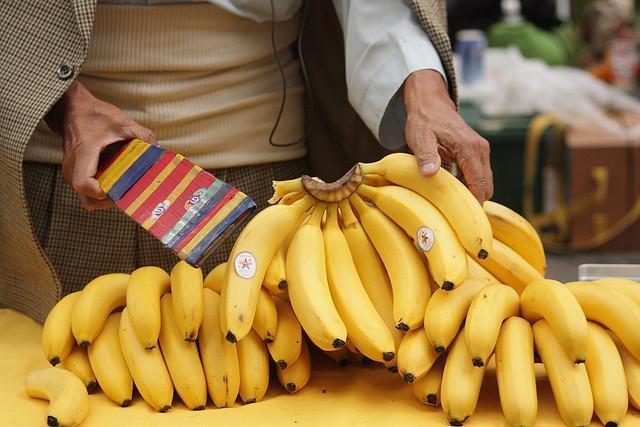How many stickers are shown on the fruit?
Give a very brief answer. 2. How many bananas are in the photo?
Give a very brief answer. 7. How many carrots are there?
Give a very brief answer. 0. 